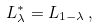<formula> <loc_0><loc_0><loc_500><loc_500>L ^ { \ast } _ { \lambda } = L _ { 1 - \lambda } \, ,</formula> 